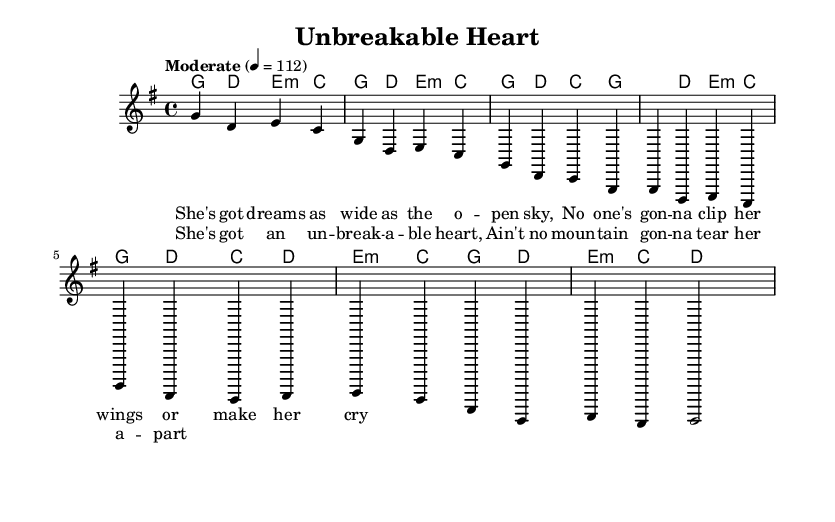What is the key signature of this music? The key signature indicated in the sheet music is one sharp, which corresponds to G major.
Answer: G major What is the time signature of this music? The time signature shown is 4/4, meaning there are four beats in each measure, and a quarter note receives one beat.
Answer: 4/4 What is the tempo marking of this piece? The tempo marking is provided as "Moderate" with a metronome indication of 112 beats per minute, giving guidance on the speed of the music.
Answer: Moderate 4 = 112 How many measures are in the chorus section? By examining the music, the chorus consists of two measures where the lyrics are provided, indicating the section's length.
Answer: 2 What is the main theme of the lyrics? The lyrics express themes of strength and independence, particularly highlighting how the protagonist is unbreakable and free to pursue her dreams, which are significant to the song's message.
Answer: Strength and independence What type of chord progression is used in the chorus? The chord progression in the chorus features a pattern that cycles through G, D, E minor, and C, reflecting a common structure in country-pop music.
Answer: G, D, E minor, C How do the lyrics emphasize the woman's independence? The lyrics specifically mention "unbreakable heart" and "no mountain gon' tear her apart," which encapsulate the theme of resilience and self-sufficiency, crucial for the portrayal of strong female characters in country music.
Answer: Resilience and self-sufficiency 